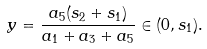<formula> <loc_0><loc_0><loc_500><loc_500>y = \frac { a _ { 5 } ( s _ { 2 } + s _ { 1 } ) } { a _ { 1 } + a _ { 3 } + a _ { 5 } } \in ( 0 , s _ { 1 } ) .</formula> 